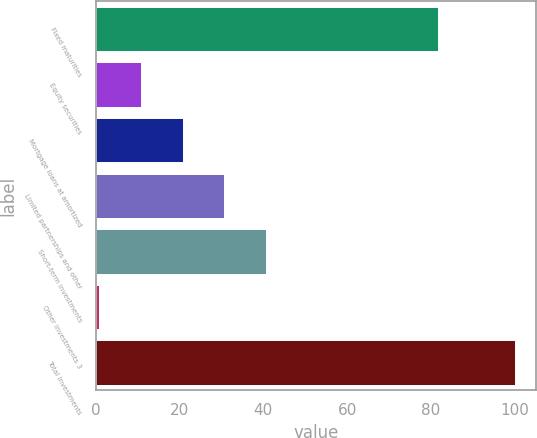Convert chart. <chart><loc_0><loc_0><loc_500><loc_500><bar_chart><fcel>Fixed maturities<fcel>Equity securities<fcel>Mortgage loans at amortized<fcel>Limited partnerships and other<fcel>Short-term investments<fcel>Other investments 3<fcel>Total investments<nl><fcel>81.7<fcel>10.81<fcel>20.72<fcel>30.63<fcel>40.54<fcel>0.9<fcel>100<nl></chart> 